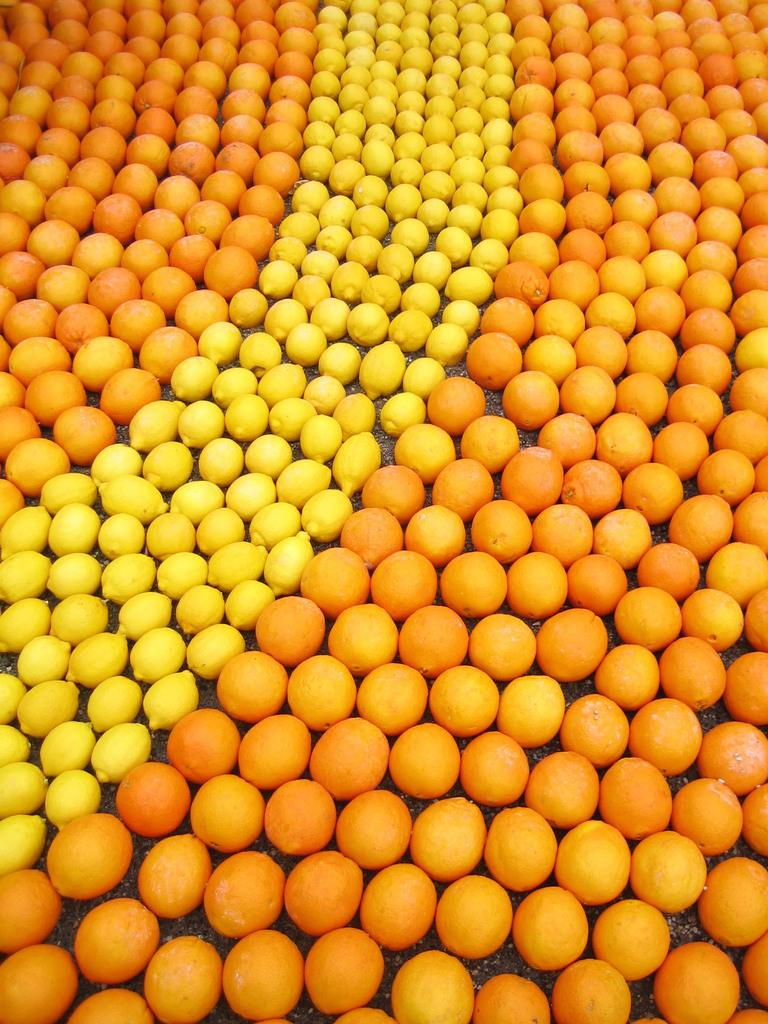What type of food is depicted in the image? There is a group of fruits in the image. Can you identify any specific fruits in the group? Yes, the fruits include oranges. What type of reward is being given to the rod in the image? There is no rod or reward present in the image; it features a group of fruits, including oranges. 